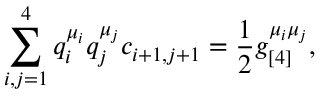<formula> <loc_0><loc_0><loc_500><loc_500>\sum _ { i , j = 1 } ^ { 4 } q _ { i } ^ { \mu _ { i } } q _ { j } ^ { \mu _ { j } } c _ { i + 1 , j + 1 } = \frac { 1 } { 2 } g _ { [ 4 ] } ^ { \mu _ { i } \mu _ { j } } ,</formula> 